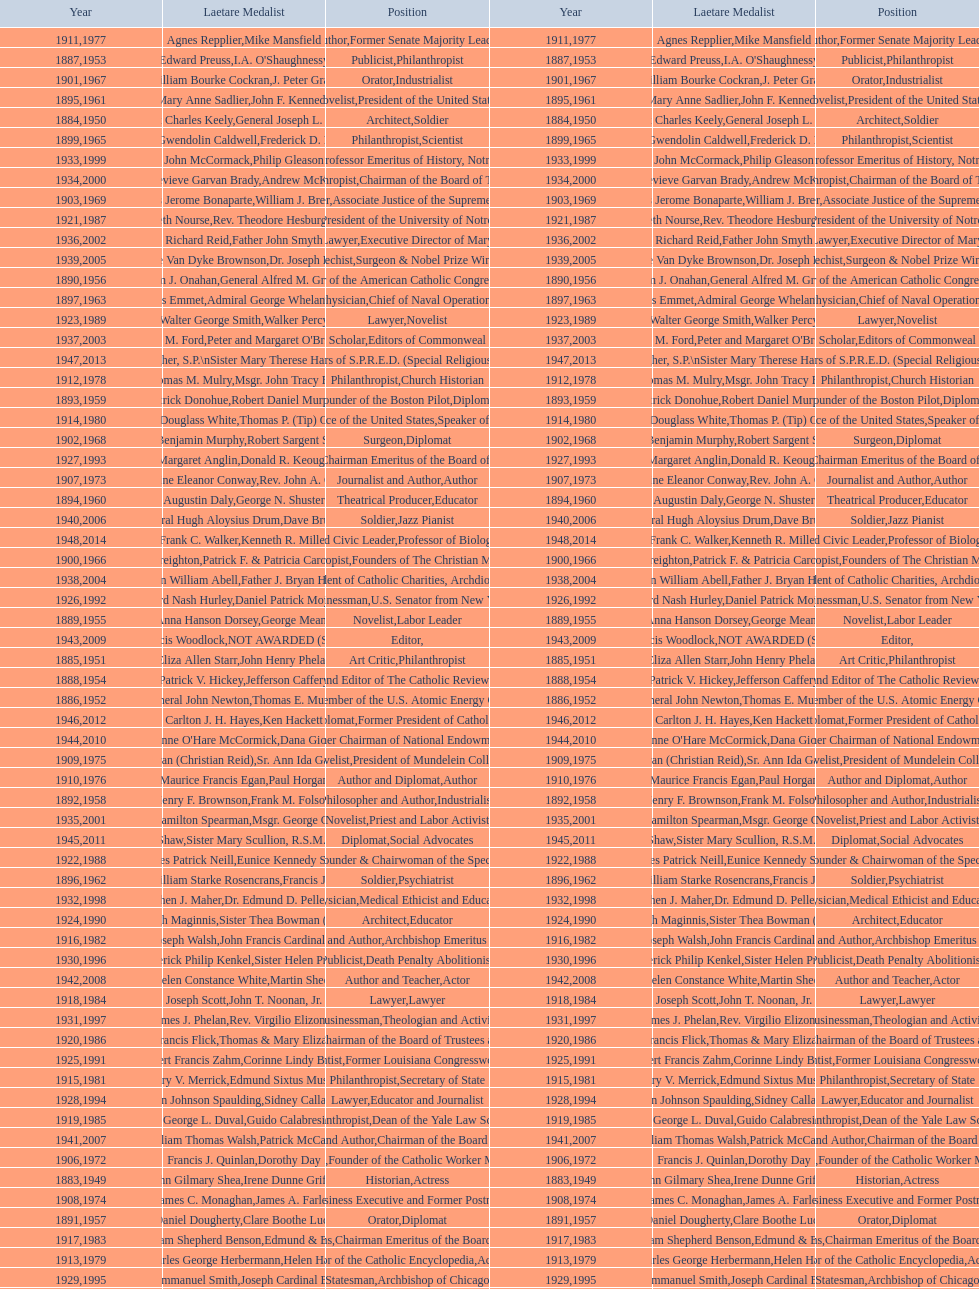What are the total number of times soldier is listed as the position on this chart? 4. 